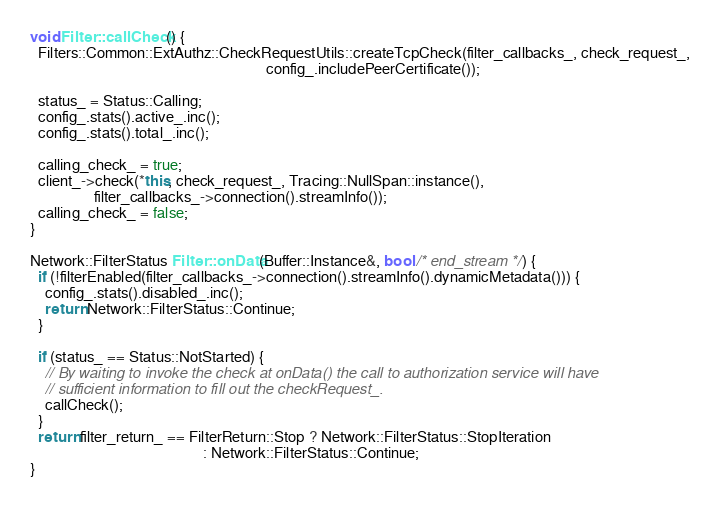<code> <loc_0><loc_0><loc_500><loc_500><_C++_>
void Filter::callCheck() {
  Filters::Common::ExtAuthz::CheckRequestUtils::createTcpCheck(filter_callbacks_, check_request_,
                                                               config_.includePeerCertificate());

  status_ = Status::Calling;
  config_.stats().active_.inc();
  config_.stats().total_.inc();

  calling_check_ = true;
  client_->check(*this, check_request_, Tracing::NullSpan::instance(),
                 filter_callbacks_->connection().streamInfo());
  calling_check_ = false;
}

Network::FilterStatus Filter::onData(Buffer::Instance&, bool /* end_stream */) {
  if (!filterEnabled(filter_callbacks_->connection().streamInfo().dynamicMetadata())) {
    config_.stats().disabled_.inc();
    return Network::FilterStatus::Continue;
  }

  if (status_ == Status::NotStarted) {
    // By waiting to invoke the check at onData() the call to authorization service will have
    // sufficient information to fill out the checkRequest_.
    callCheck();
  }
  return filter_return_ == FilterReturn::Stop ? Network::FilterStatus::StopIteration
                                              : Network::FilterStatus::Continue;
}
</code> 